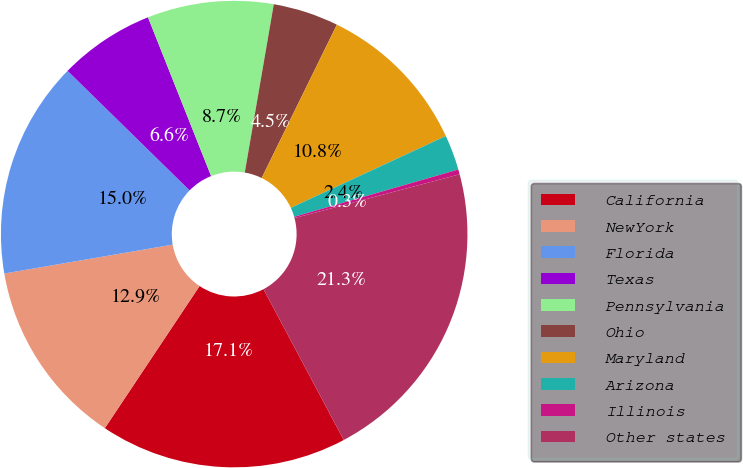Convert chart. <chart><loc_0><loc_0><loc_500><loc_500><pie_chart><fcel>California<fcel>NewYork<fcel>Florida<fcel>Texas<fcel>Pennsylvania<fcel>Ohio<fcel>Maryland<fcel>Arizona<fcel>Illinois<fcel>Other states<nl><fcel>17.14%<fcel>12.94%<fcel>15.04%<fcel>6.64%<fcel>8.74%<fcel>4.54%<fcel>10.84%<fcel>2.44%<fcel>0.34%<fcel>21.34%<nl></chart> 